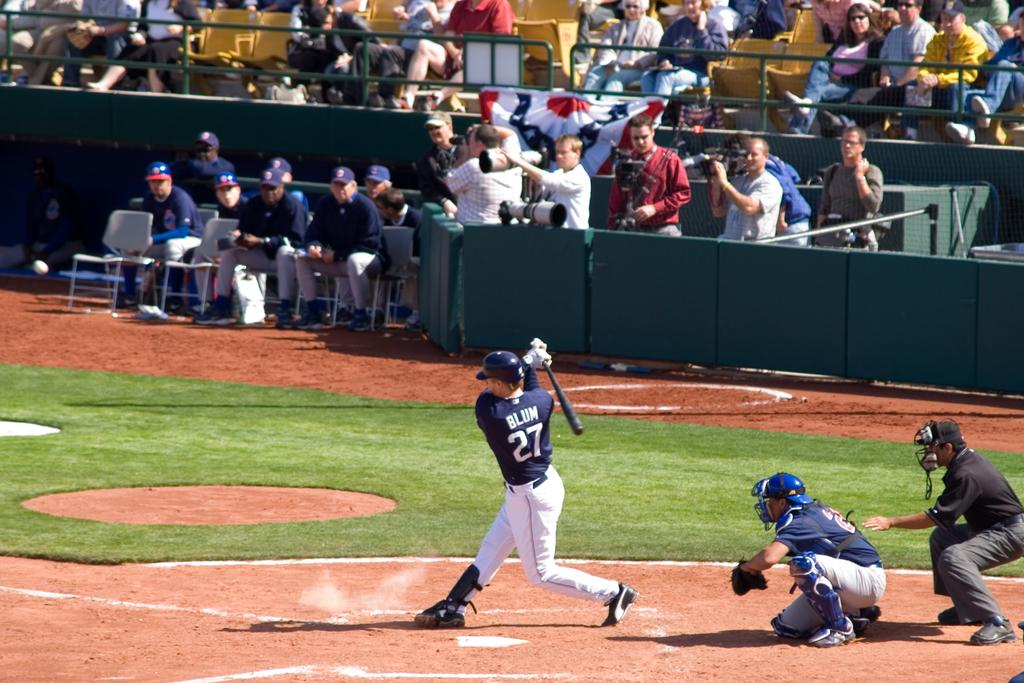<image>
Give a short and clear explanation of the subsequent image. A baseball player with the name Blum and the number 27 is taking a swing. 